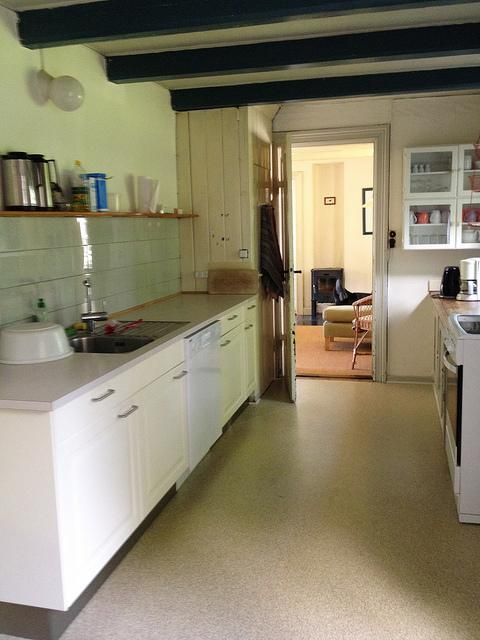What is the most likely activity the person on the yellow chair is doing?

Choices:
A) video game
B) watching tv
C) singing
D) cooking watching tv 